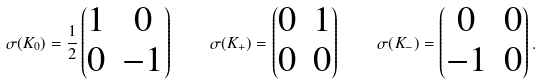Convert formula to latex. <formula><loc_0><loc_0><loc_500><loc_500>\sigma ( K _ { 0 } ) = \frac { 1 } { 2 } \begin{pmatrix} 1 & 0 \\ 0 & - 1 \end{pmatrix} \quad \sigma ( K _ { + } ) = \begin{pmatrix} 0 & 1 \\ 0 & 0 \end{pmatrix} \quad \sigma ( K _ { - } ) = \begin{pmatrix} 0 & 0 \\ - 1 & 0 \end{pmatrix} .</formula> 